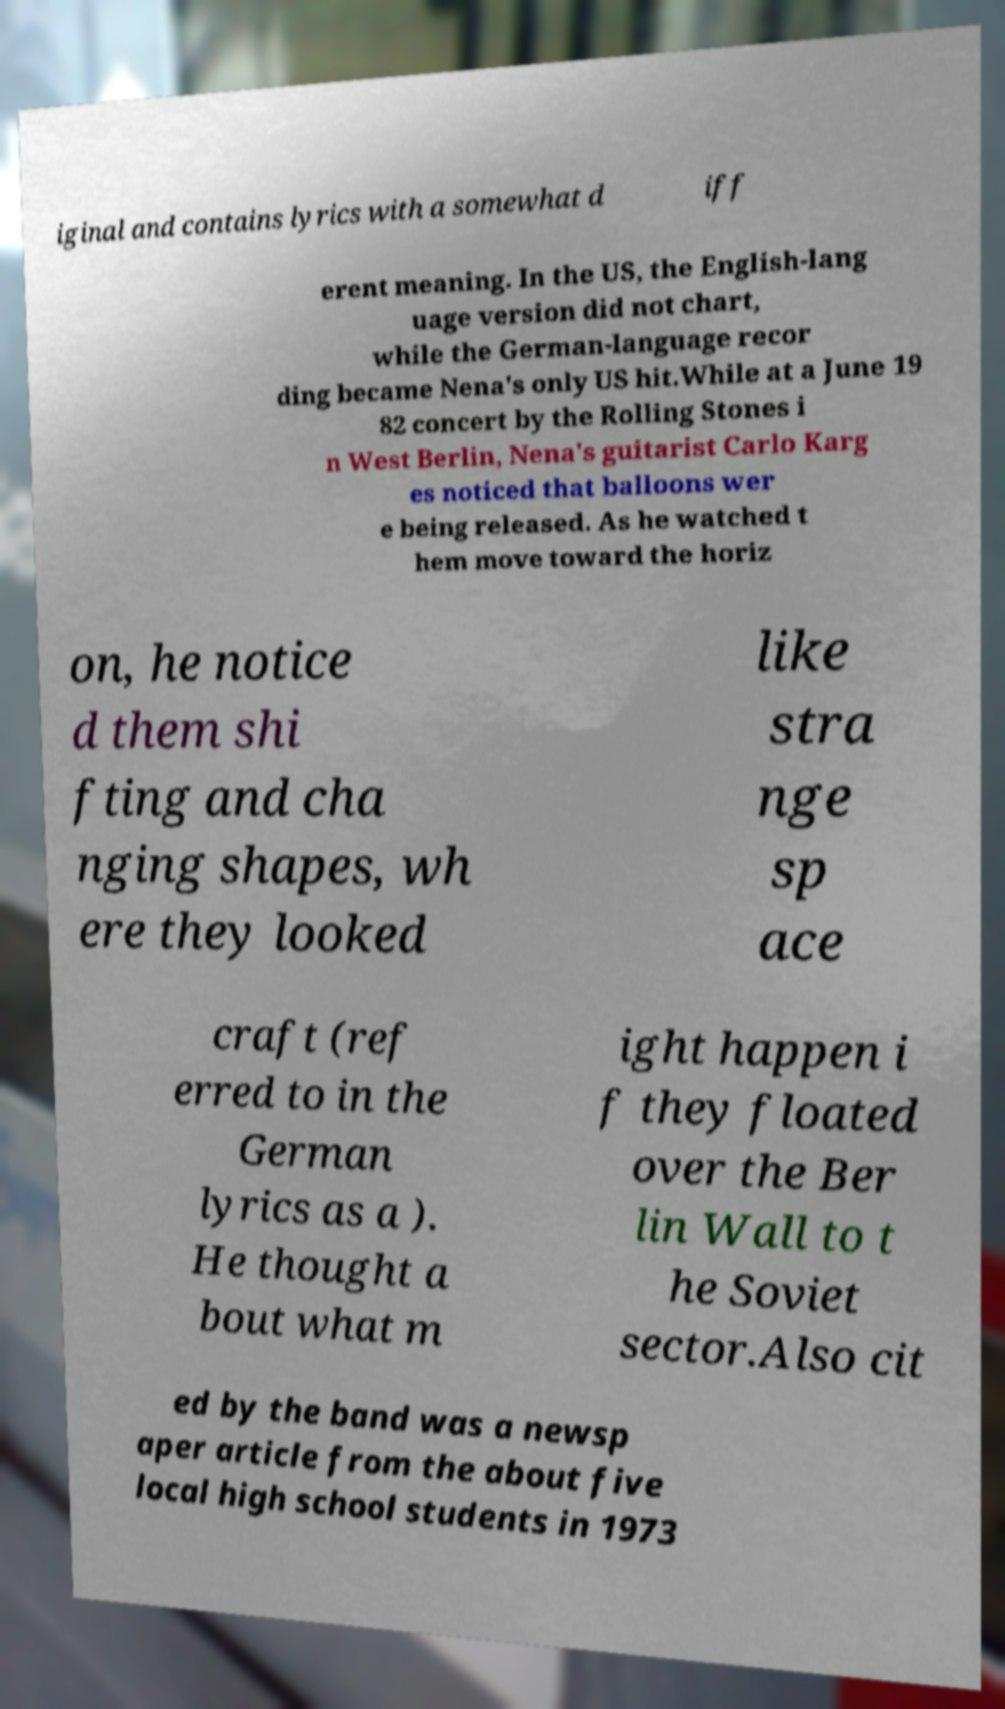Can you accurately transcribe the text from the provided image for me? iginal and contains lyrics with a somewhat d iff erent meaning. In the US, the English-lang uage version did not chart, while the German-language recor ding became Nena's only US hit.While at a June 19 82 concert by the Rolling Stones i n West Berlin, Nena's guitarist Carlo Karg es noticed that balloons wer e being released. As he watched t hem move toward the horiz on, he notice d them shi fting and cha nging shapes, wh ere they looked like stra nge sp ace craft (ref erred to in the German lyrics as a ). He thought a bout what m ight happen i f they floated over the Ber lin Wall to t he Soviet sector.Also cit ed by the band was a newsp aper article from the about five local high school students in 1973 